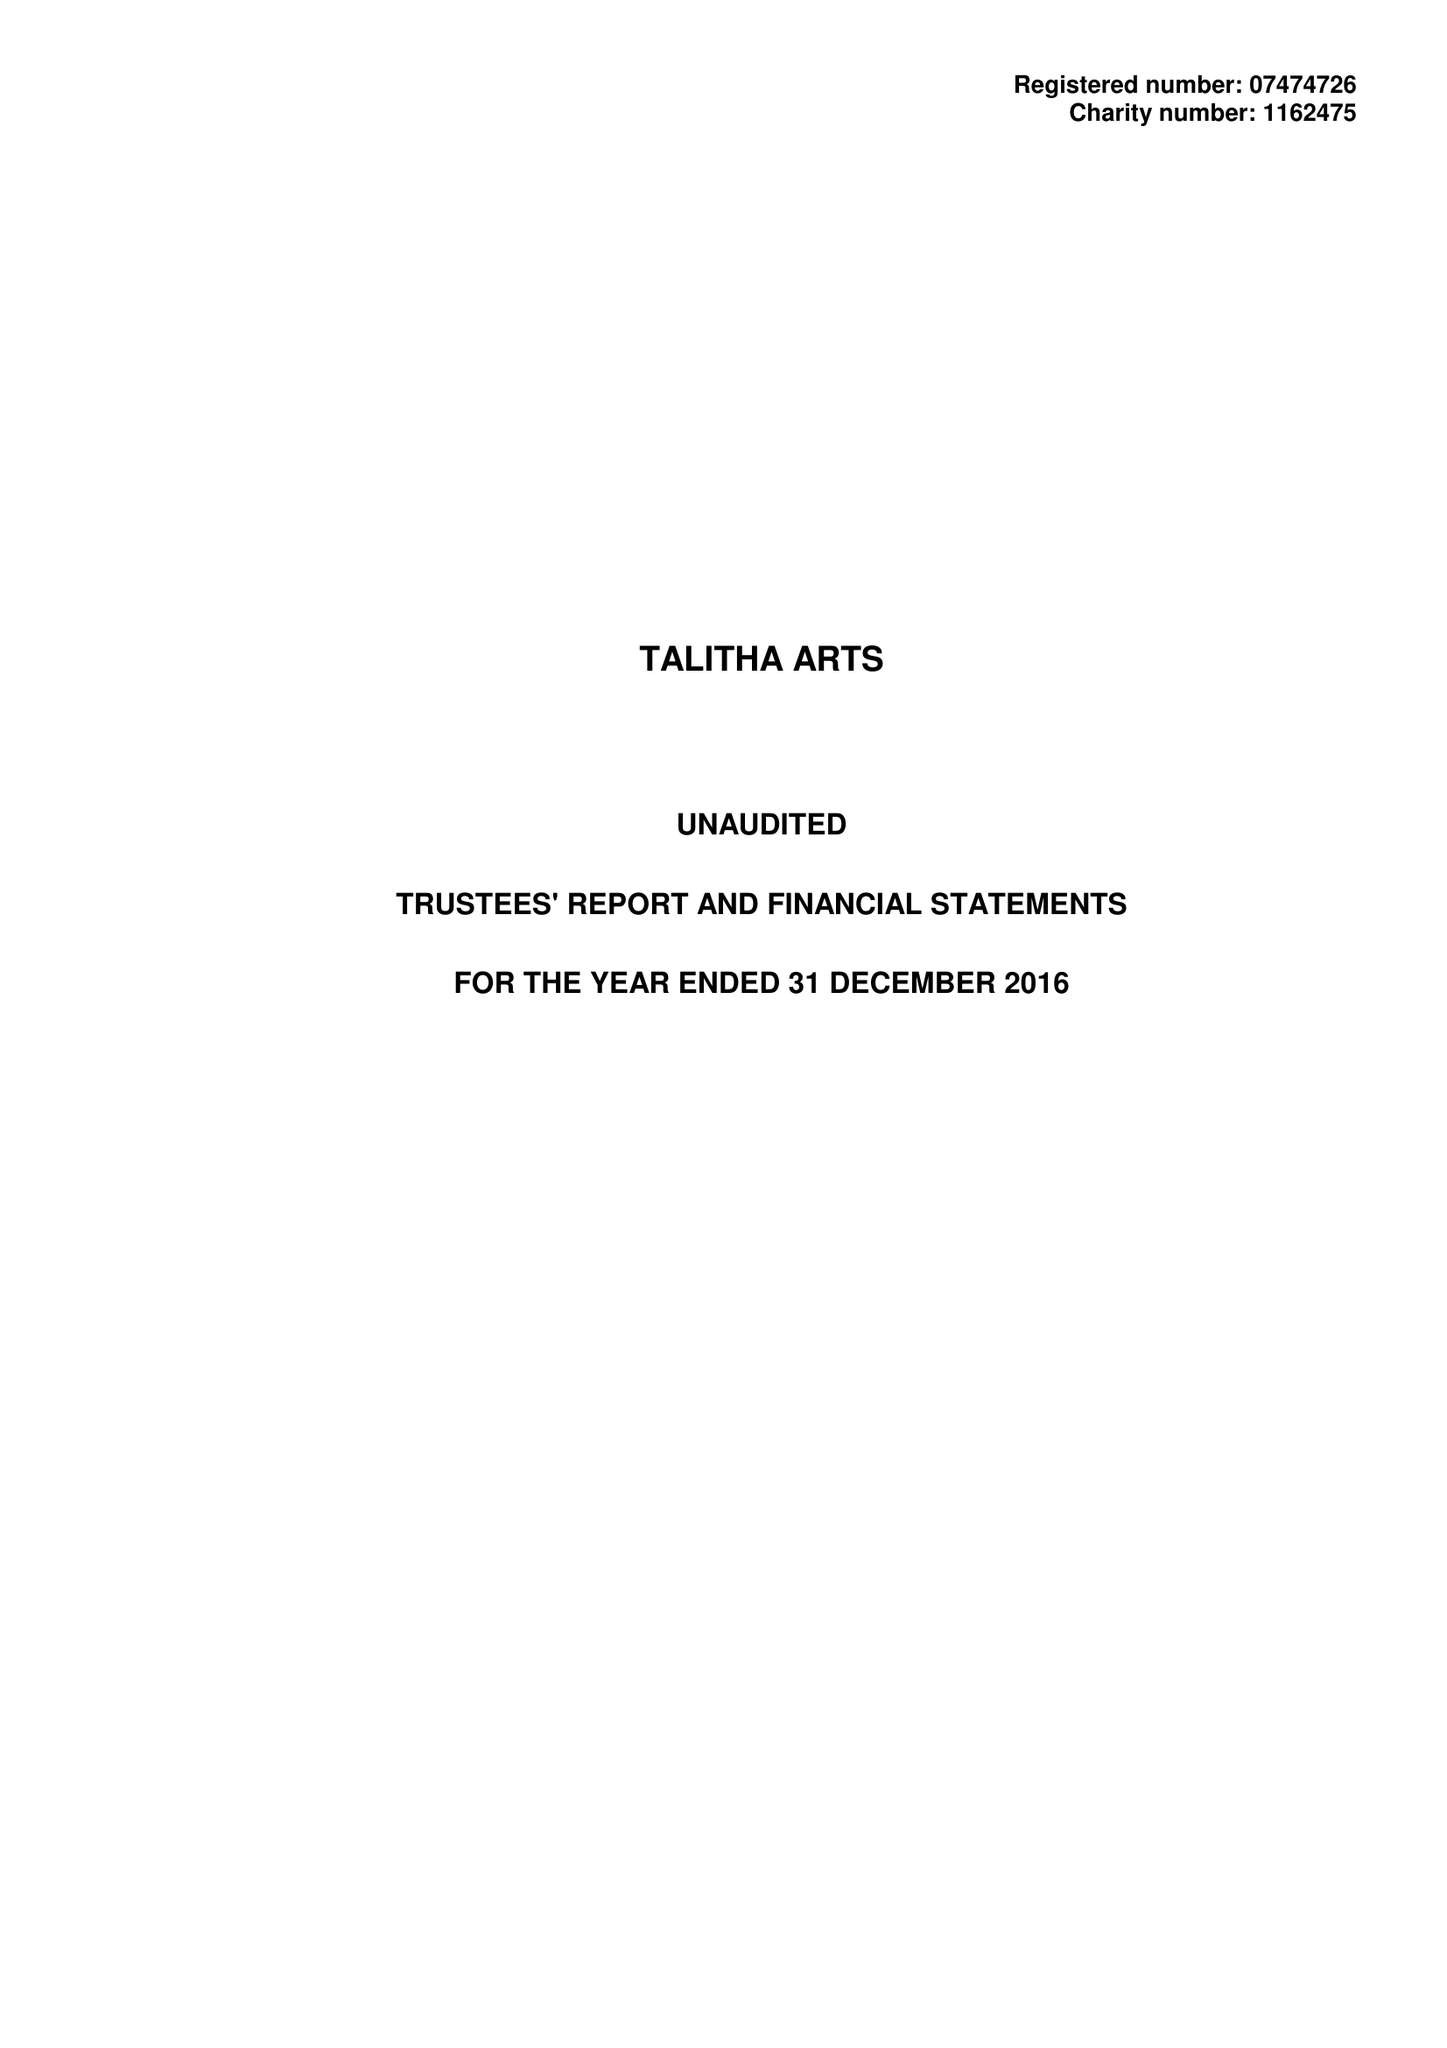What is the value for the address__post_town?
Answer the question using a single word or phrase. TEDDINGTON 